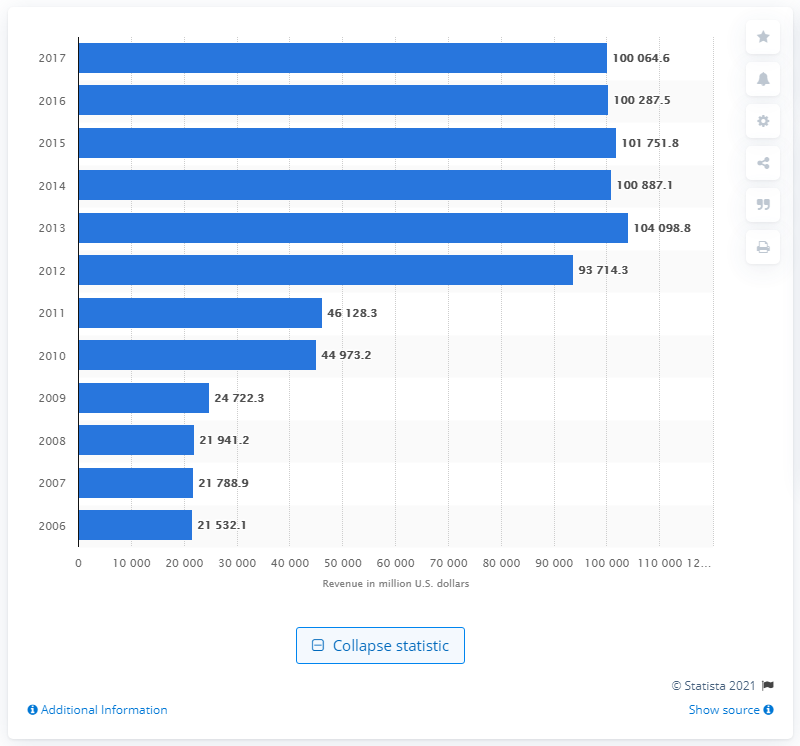Specify some key components in this picture. In 2008, Express Scripts generated approximately $219,412.20 in revenue. 